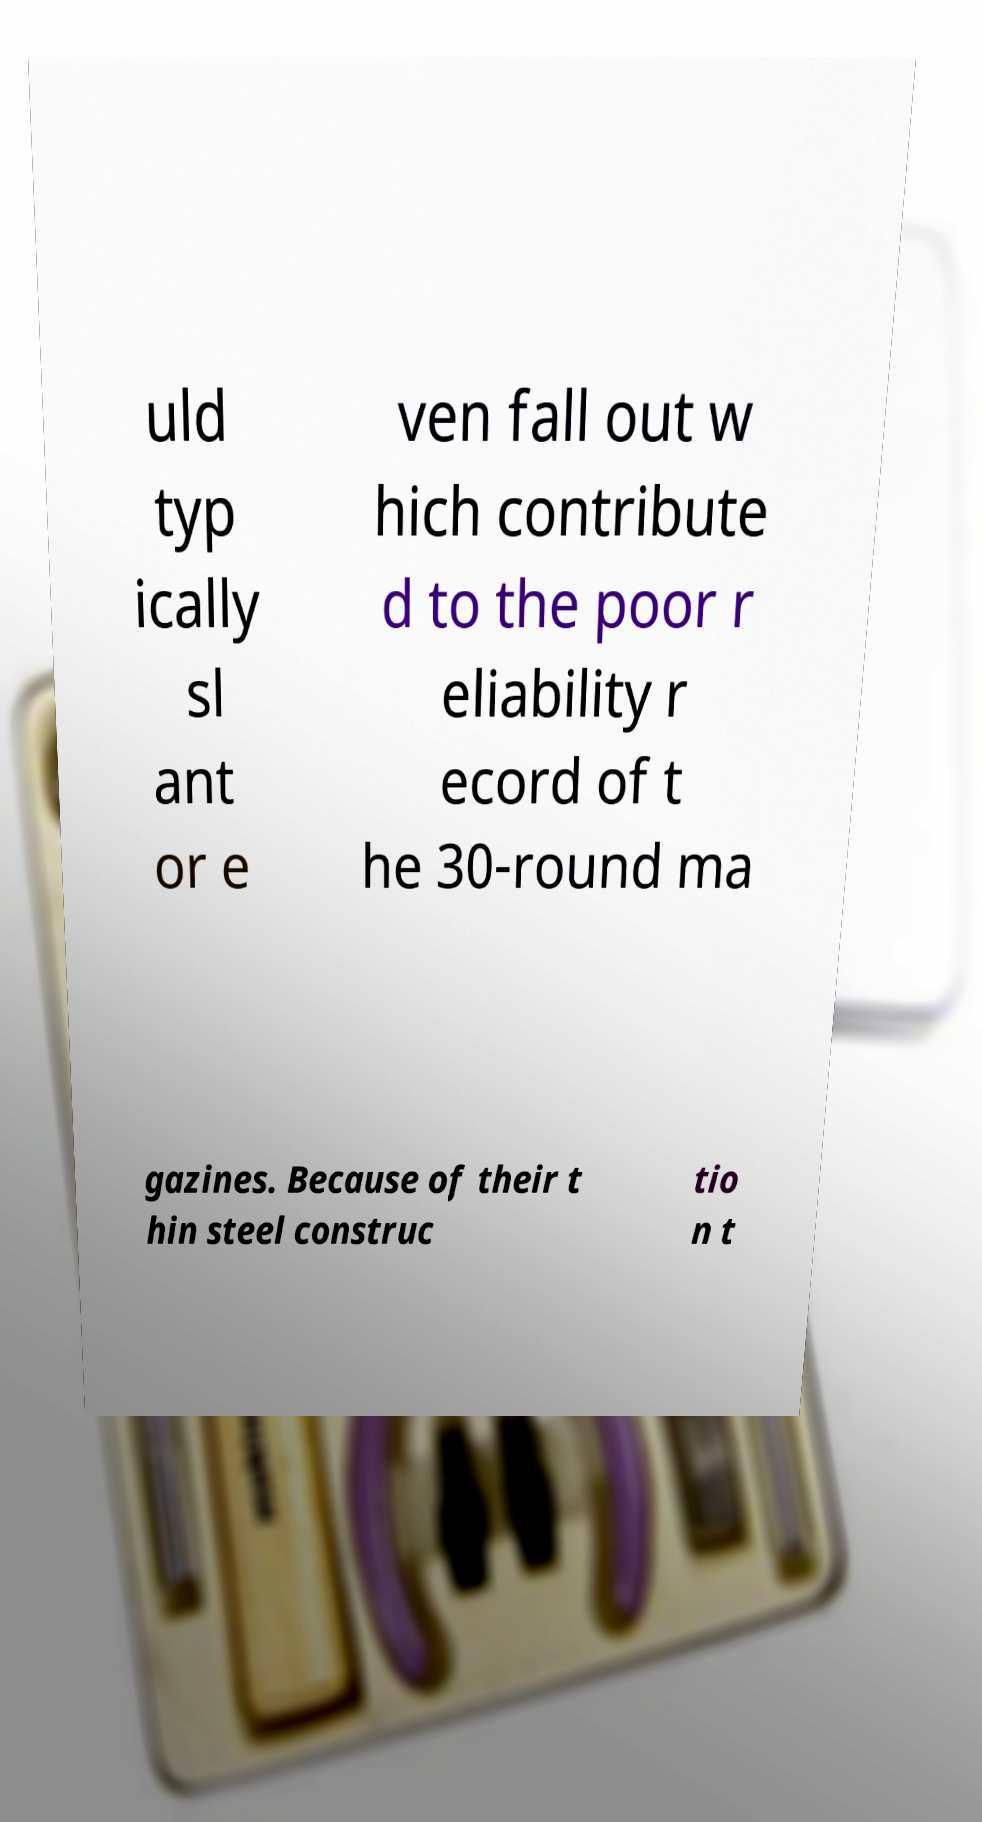I need the written content from this picture converted into text. Can you do that? uld typ ically sl ant or e ven fall out w hich contribute d to the poor r eliability r ecord of t he 30-round ma gazines. Because of their t hin steel construc tio n t 